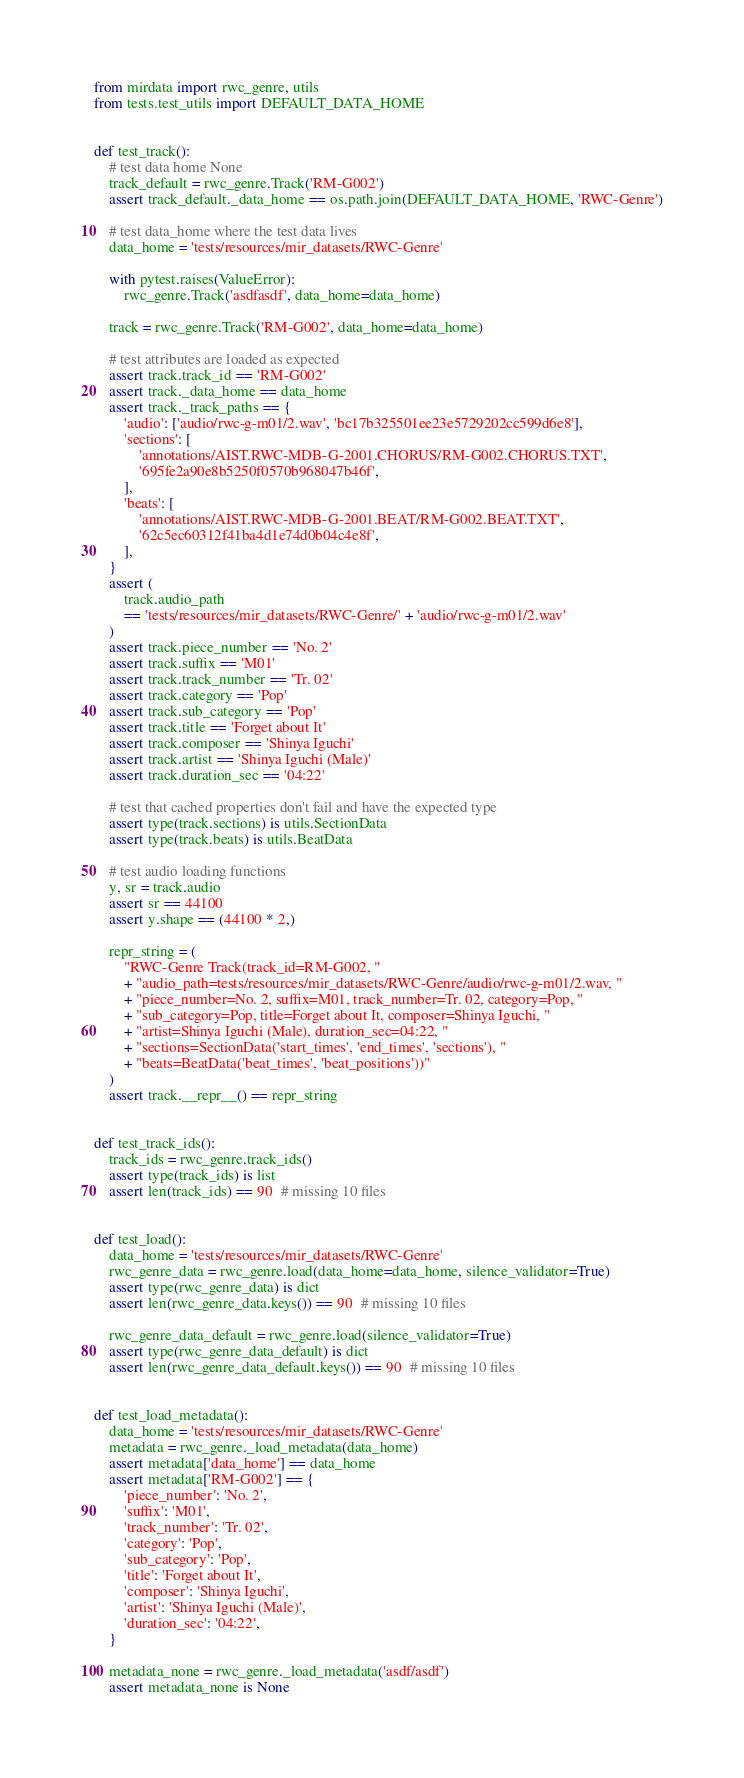<code> <loc_0><loc_0><loc_500><loc_500><_Python_>
from mirdata import rwc_genre, utils
from tests.test_utils import DEFAULT_DATA_HOME


def test_track():
    # test data home None
    track_default = rwc_genre.Track('RM-G002')
    assert track_default._data_home == os.path.join(DEFAULT_DATA_HOME, 'RWC-Genre')

    # test data_home where the test data lives
    data_home = 'tests/resources/mir_datasets/RWC-Genre'

    with pytest.raises(ValueError):
        rwc_genre.Track('asdfasdf', data_home=data_home)

    track = rwc_genre.Track('RM-G002', data_home=data_home)

    # test attributes are loaded as expected
    assert track.track_id == 'RM-G002'
    assert track._data_home == data_home
    assert track._track_paths == {
        'audio': ['audio/rwc-g-m01/2.wav', 'bc17b325501ee23e5729202cc599d6e8'],
        'sections': [
            'annotations/AIST.RWC-MDB-G-2001.CHORUS/RM-G002.CHORUS.TXT',
            '695fe2a90e8b5250f0570b968047b46f',
        ],
        'beats': [
            'annotations/AIST.RWC-MDB-G-2001.BEAT/RM-G002.BEAT.TXT',
            '62c5ec60312f41ba4d1e74d0b04c4e8f',
        ],
    }
    assert (
        track.audio_path
        == 'tests/resources/mir_datasets/RWC-Genre/' + 'audio/rwc-g-m01/2.wav'
    )
    assert track.piece_number == 'No. 2'
    assert track.suffix == 'M01'
    assert track.track_number == 'Tr. 02'
    assert track.category == 'Pop'
    assert track.sub_category == 'Pop'
    assert track.title == 'Forget about It'
    assert track.composer == 'Shinya Iguchi'
    assert track.artist == 'Shinya Iguchi (Male)'
    assert track.duration_sec == '04:22'

    # test that cached properties don't fail and have the expected type
    assert type(track.sections) is utils.SectionData
    assert type(track.beats) is utils.BeatData

    # test audio loading functions
    y, sr = track.audio
    assert sr == 44100
    assert y.shape == (44100 * 2,)

    repr_string = (
        "RWC-Genre Track(track_id=RM-G002, "
        + "audio_path=tests/resources/mir_datasets/RWC-Genre/audio/rwc-g-m01/2.wav, "
        + "piece_number=No. 2, suffix=M01, track_number=Tr. 02, category=Pop, "
        + "sub_category=Pop, title=Forget about It, composer=Shinya Iguchi, "
        + "artist=Shinya Iguchi (Male), duration_sec=04:22, "
        + "sections=SectionData('start_times', 'end_times', 'sections'), "
        + "beats=BeatData('beat_times', 'beat_positions'))"
    )
    assert track.__repr__() == repr_string


def test_track_ids():
    track_ids = rwc_genre.track_ids()
    assert type(track_ids) is list
    assert len(track_ids) == 90  # missing 10 files


def test_load():
    data_home = 'tests/resources/mir_datasets/RWC-Genre'
    rwc_genre_data = rwc_genre.load(data_home=data_home, silence_validator=True)
    assert type(rwc_genre_data) is dict
    assert len(rwc_genre_data.keys()) == 90  # missing 10 files

    rwc_genre_data_default = rwc_genre.load(silence_validator=True)
    assert type(rwc_genre_data_default) is dict
    assert len(rwc_genre_data_default.keys()) == 90  # missing 10 files


def test_load_metadata():
    data_home = 'tests/resources/mir_datasets/RWC-Genre'
    metadata = rwc_genre._load_metadata(data_home)
    assert metadata['data_home'] == data_home
    assert metadata['RM-G002'] == {
        'piece_number': 'No. 2',
        'suffix': 'M01',
        'track_number': 'Tr. 02',
        'category': 'Pop',
        'sub_category': 'Pop',
        'title': 'Forget about It',
        'composer': 'Shinya Iguchi',
        'artist': 'Shinya Iguchi (Male)',
        'duration_sec': '04:22',
    }

    metadata_none = rwc_genre._load_metadata('asdf/asdf')
    assert metadata_none is None

</code> 